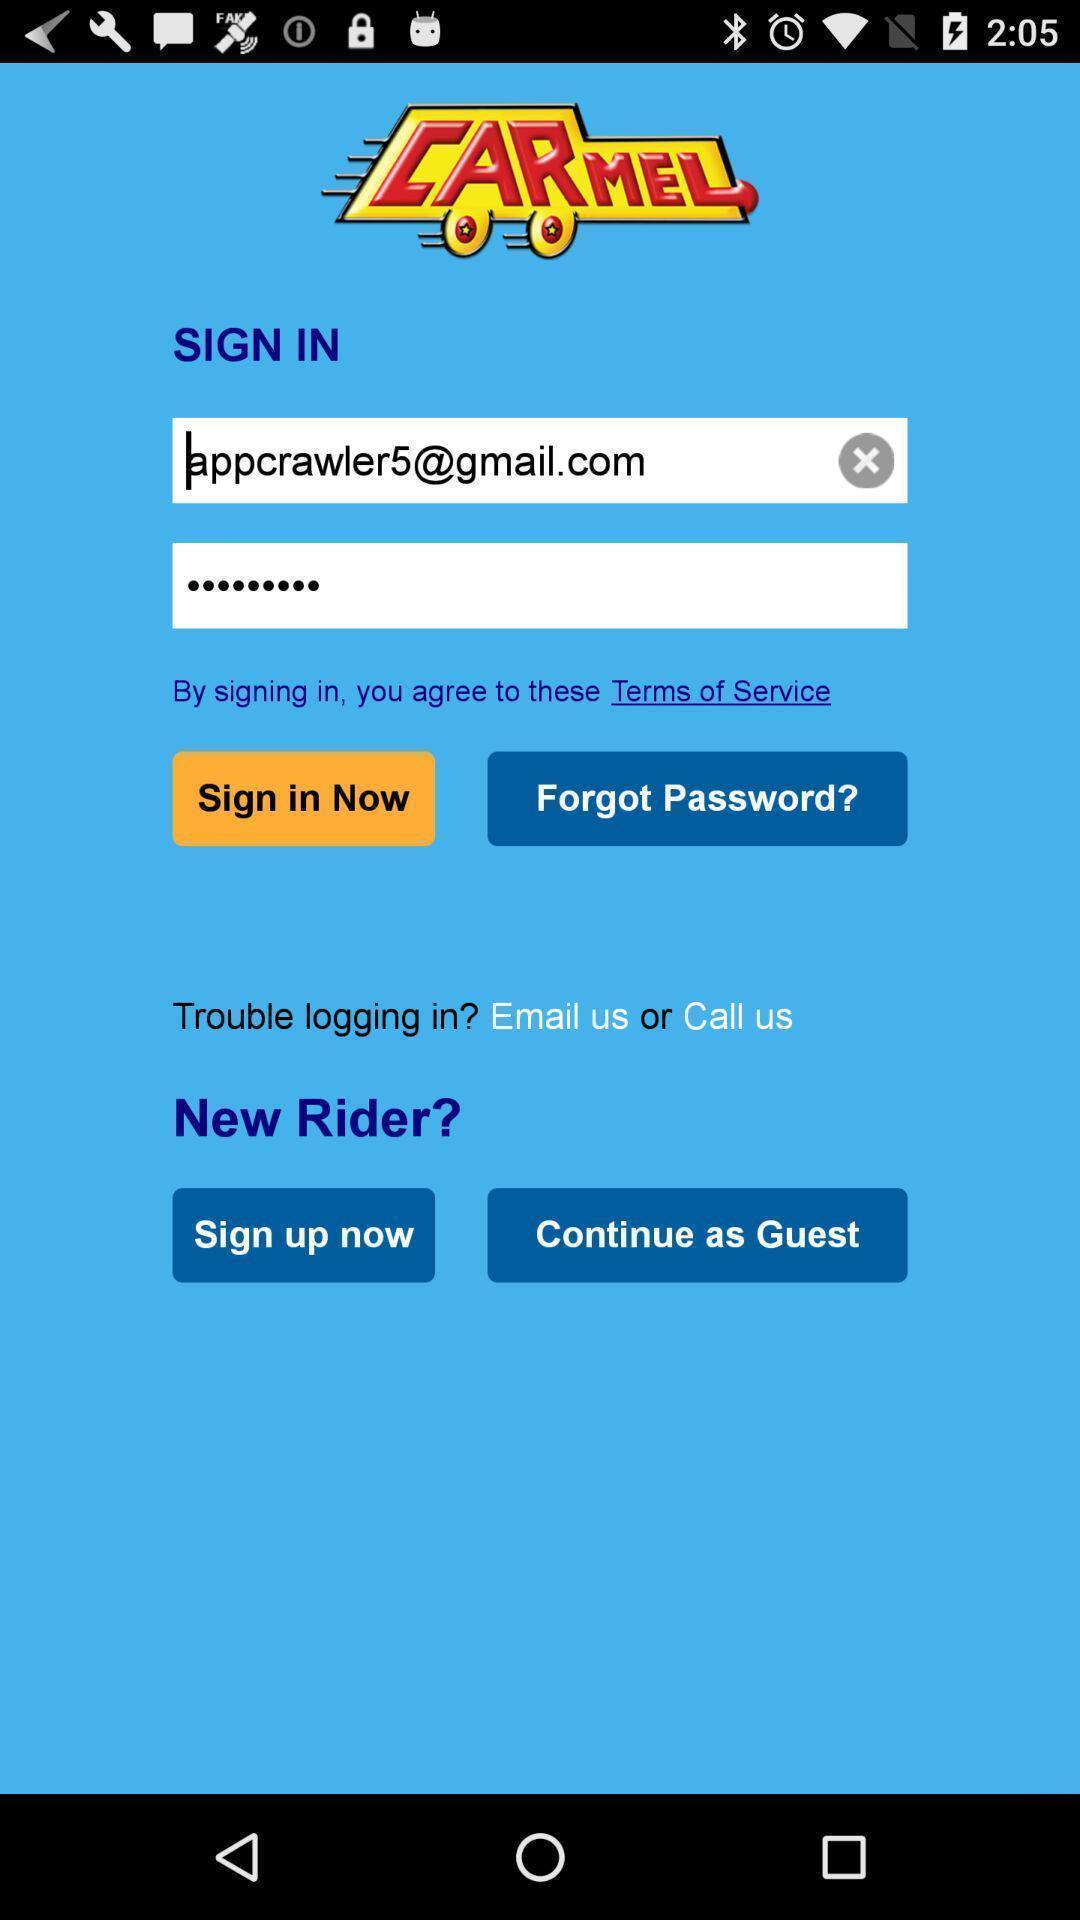What can you discern from this picture? Sign in page. 